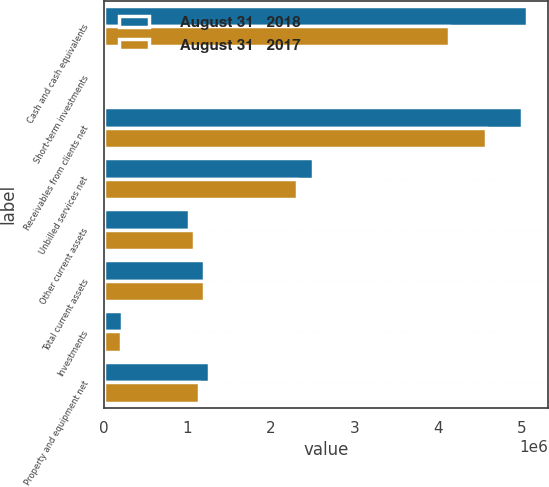<chart> <loc_0><loc_0><loc_500><loc_500><stacked_bar_chart><ecel><fcel>Cash and cash equivalents<fcel>Short-term investments<fcel>Receivables from clients net<fcel>Unbilled services net<fcel>Other current assets<fcel>Total current assets<fcel>Investments<fcel>Property and equipment net<nl><fcel>August 31   2018<fcel>5.06136e+06<fcel>3192<fcel>4.99645e+06<fcel>2.49991e+06<fcel>1.02464e+06<fcel>1.20231e+06<fcel>215532<fcel>1.26402e+06<nl><fcel>August 31   2017<fcel>4.12686e+06<fcel>3011<fcel>4.56921e+06<fcel>2.31604e+06<fcel>1.08216e+06<fcel>1.20231e+06<fcel>211610<fcel>1.1406e+06<nl></chart> 